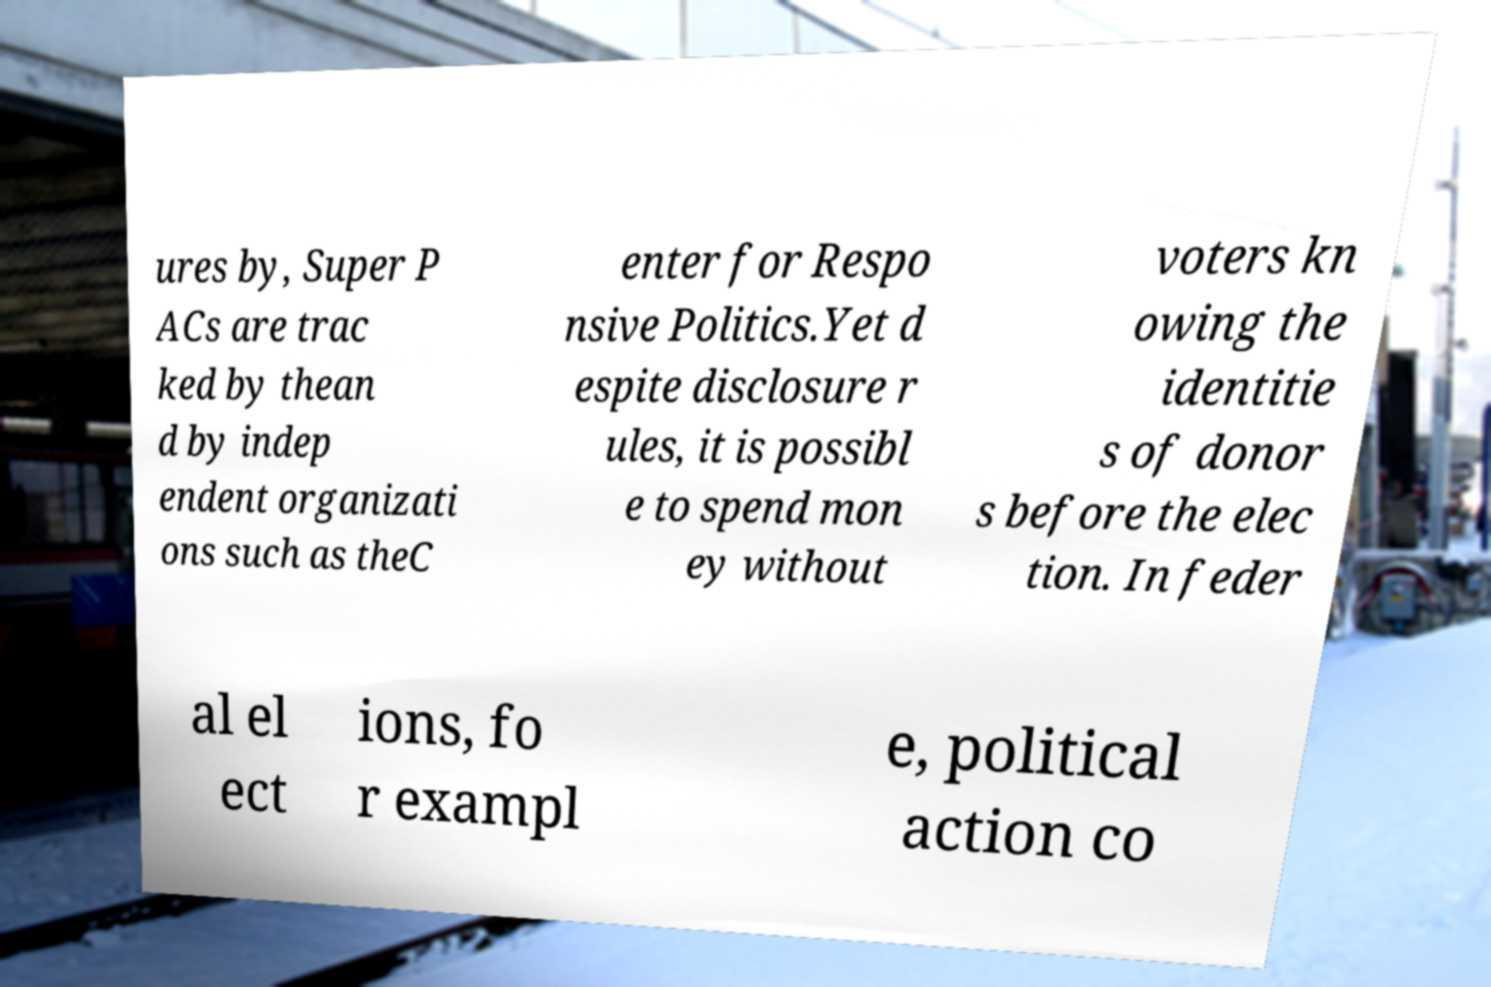Please read and relay the text visible in this image. What does it say? ures by, Super P ACs are trac ked by thean d by indep endent organizati ons such as theC enter for Respo nsive Politics.Yet d espite disclosure r ules, it is possibl e to spend mon ey without voters kn owing the identitie s of donor s before the elec tion. In feder al el ect ions, fo r exampl e, political action co 